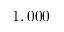Convert formula to latex. <formula><loc_0><loc_0><loc_500><loc_500>1 , 0 0 0</formula> 